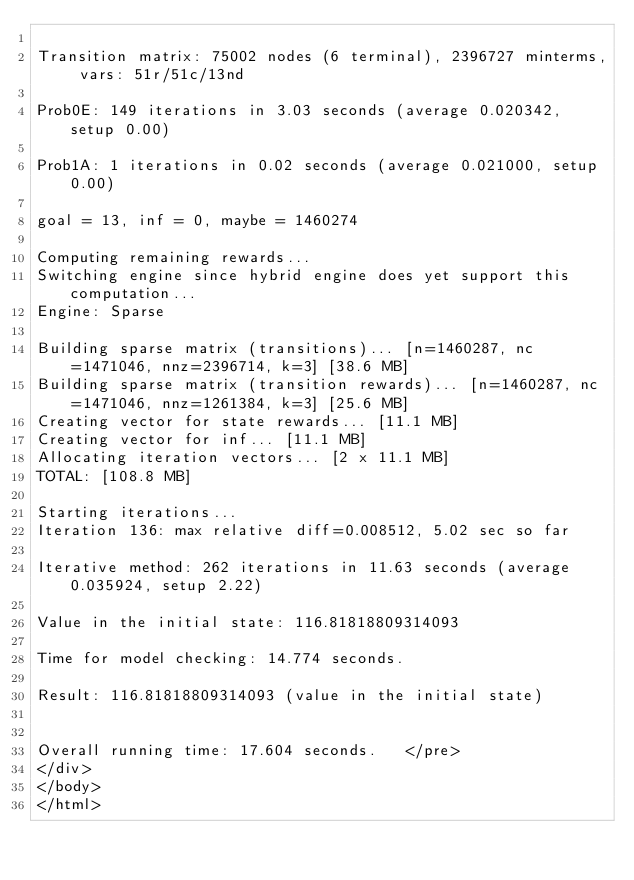<code> <loc_0><loc_0><loc_500><loc_500><_HTML_>
Transition matrix: 75002 nodes (6 terminal), 2396727 minterms, vars: 51r/51c/13nd

Prob0E: 149 iterations in 3.03 seconds (average 0.020342, setup 0.00)

Prob1A: 1 iterations in 0.02 seconds (average 0.021000, setup 0.00)

goal = 13, inf = 0, maybe = 1460274

Computing remaining rewards...
Switching engine since hybrid engine does yet support this computation...
Engine: Sparse

Building sparse matrix (transitions)... [n=1460287, nc=1471046, nnz=2396714, k=3] [38.6 MB]
Building sparse matrix (transition rewards)... [n=1460287, nc=1471046, nnz=1261384, k=3] [25.6 MB]
Creating vector for state rewards... [11.1 MB]
Creating vector for inf... [11.1 MB]
Allocating iteration vectors... [2 x 11.1 MB]
TOTAL: [108.8 MB]

Starting iterations...
Iteration 136: max relative diff=0.008512, 5.02 sec so far

Iterative method: 262 iterations in 11.63 seconds (average 0.035924, setup 2.22)

Value in the initial state: 116.81818809314093

Time for model checking: 14.774 seconds.

Result: 116.81818809314093 (value in the initial state)


Overall running time: 17.604 seconds.	</pre>
</div>
</body>
</html>
</code> 